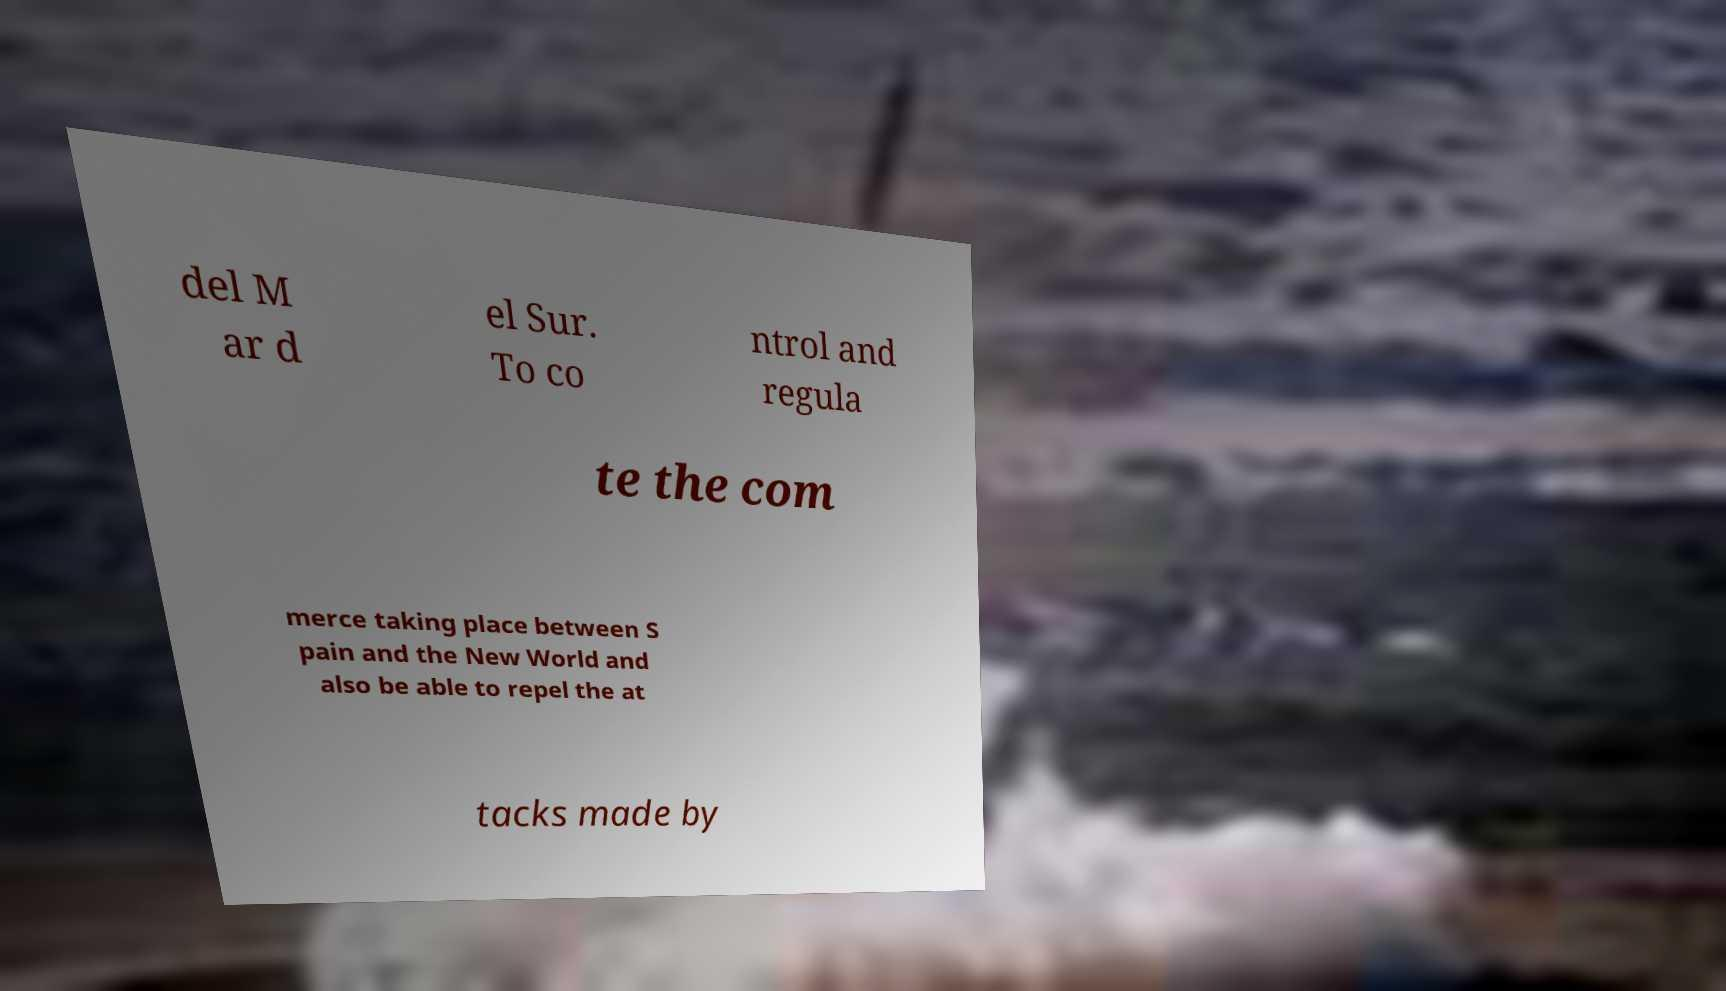I need the written content from this picture converted into text. Can you do that? del M ar d el Sur. To co ntrol and regula te the com merce taking place between S pain and the New World and also be able to repel the at tacks made by 